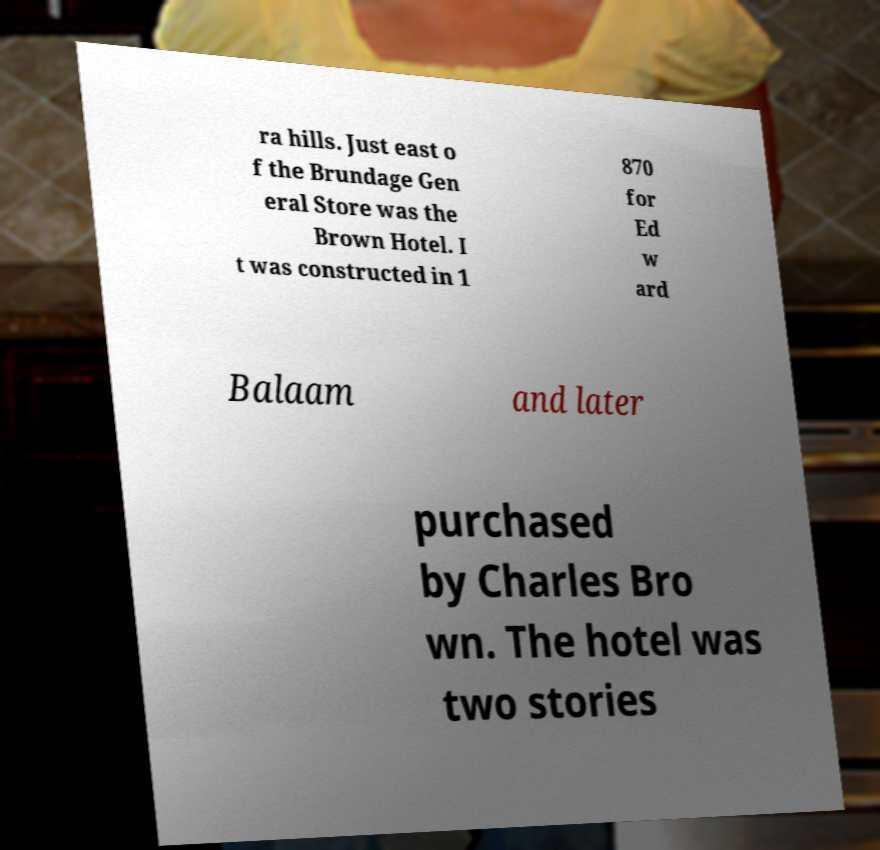Please identify and transcribe the text found in this image. ra hills. Just east o f the Brundage Gen eral Store was the Brown Hotel. I t was constructed in 1 870 for Ed w ard Balaam and later purchased by Charles Bro wn. The hotel was two stories 